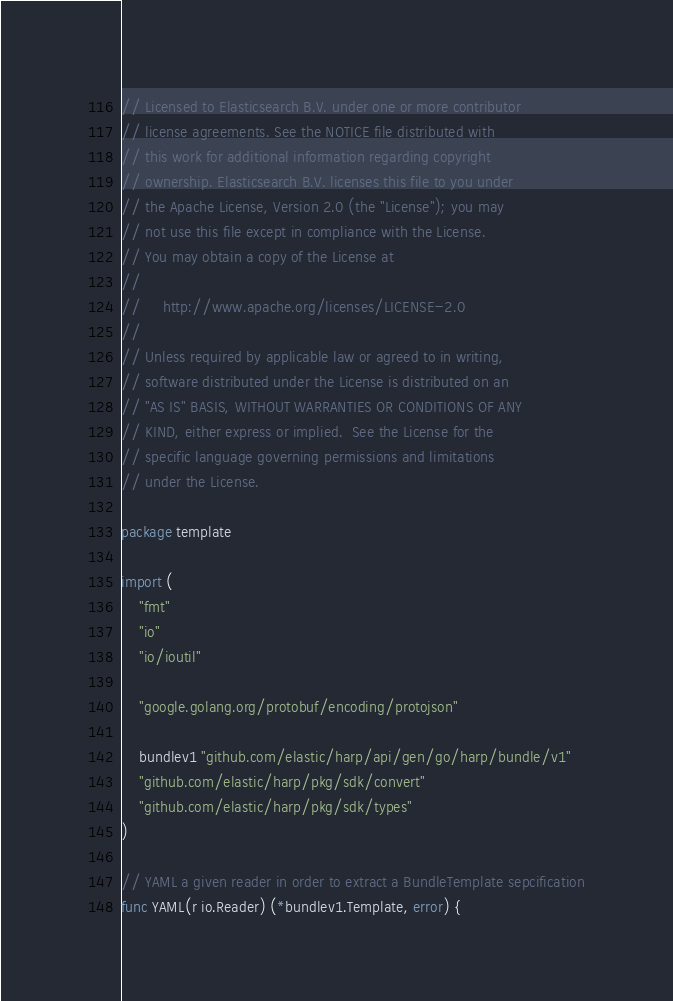Convert code to text. <code><loc_0><loc_0><loc_500><loc_500><_Go_>// Licensed to Elasticsearch B.V. under one or more contributor
// license agreements. See the NOTICE file distributed with
// this work for additional information regarding copyright
// ownership. Elasticsearch B.V. licenses this file to you under
// the Apache License, Version 2.0 (the "License"); you may
// not use this file except in compliance with the License.
// You may obtain a copy of the License at
//
//     http://www.apache.org/licenses/LICENSE-2.0
//
// Unless required by applicable law or agreed to in writing,
// software distributed under the License is distributed on an
// "AS IS" BASIS, WITHOUT WARRANTIES OR CONDITIONS OF ANY
// KIND, either express or implied.  See the License for the
// specific language governing permissions and limitations
// under the License.

package template

import (
	"fmt"
	"io"
	"io/ioutil"

	"google.golang.org/protobuf/encoding/protojson"

	bundlev1 "github.com/elastic/harp/api/gen/go/harp/bundle/v1"
	"github.com/elastic/harp/pkg/sdk/convert"
	"github.com/elastic/harp/pkg/sdk/types"
)

// YAML a given reader in order to extract a BundleTemplate sepcification
func YAML(r io.Reader) (*bundlev1.Template, error) {</code> 